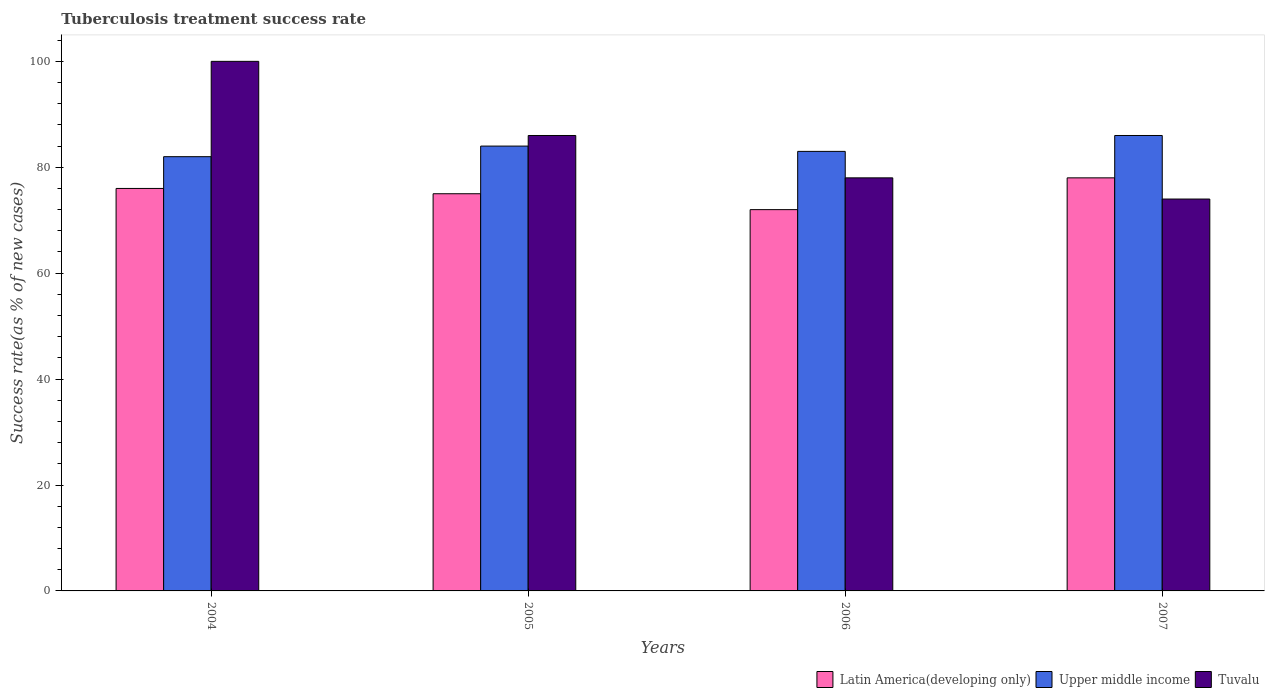How many groups of bars are there?
Your answer should be compact. 4. How many bars are there on the 1st tick from the right?
Offer a terse response. 3. What is the label of the 1st group of bars from the left?
Your answer should be very brief. 2004. In how many cases, is the number of bars for a given year not equal to the number of legend labels?
Offer a very short reply. 0. What is the tuberculosis treatment success rate in Upper middle income in 2006?
Keep it short and to the point. 83. Across all years, what is the maximum tuberculosis treatment success rate in Upper middle income?
Keep it short and to the point. 86. Across all years, what is the minimum tuberculosis treatment success rate in Upper middle income?
Your response must be concise. 82. In which year was the tuberculosis treatment success rate in Upper middle income minimum?
Provide a short and direct response. 2004. What is the total tuberculosis treatment success rate in Tuvalu in the graph?
Give a very brief answer. 338. What is the difference between the tuberculosis treatment success rate in Upper middle income in 2004 and that in 2005?
Offer a very short reply. -2. What is the difference between the tuberculosis treatment success rate in Upper middle income in 2005 and the tuberculosis treatment success rate in Latin America(developing only) in 2006?
Your answer should be very brief. 12. What is the average tuberculosis treatment success rate in Tuvalu per year?
Ensure brevity in your answer.  84.5. What is the ratio of the tuberculosis treatment success rate in Tuvalu in 2006 to that in 2007?
Give a very brief answer. 1.05. Is the difference between the tuberculosis treatment success rate in Latin America(developing only) in 2004 and 2005 greater than the difference between the tuberculosis treatment success rate in Tuvalu in 2004 and 2005?
Your answer should be very brief. No. What is the difference between the highest and the second highest tuberculosis treatment success rate in Latin America(developing only)?
Your response must be concise. 2. What is the difference between the highest and the lowest tuberculosis treatment success rate in Latin America(developing only)?
Your answer should be very brief. 6. In how many years, is the tuberculosis treatment success rate in Upper middle income greater than the average tuberculosis treatment success rate in Upper middle income taken over all years?
Give a very brief answer. 2. Is the sum of the tuberculosis treatment success rate in Latin America(developing only) in 2006 and 2007 greater than the maximum tuberculosis treatment success rate in Upper middle income across all years?
Offer a terse response. Yes. What does the 2nd bar from the left in 2005 represents?
Keep it short and to the point. Upper middle income. What does the 1st bar from the right in 2006 represents?
Offer a terse response. Tuvalu. How many bars are there?
Offer a very short reply. 12. Are all the bars in the graph horizontal?
Give a very brief answer. No. How many years are there in the graph?
Your answer should be compact. 4. What is the difference between two consecutive major ticks on the Y-axis?
Offer a terse response. 20. How are the legend labels stacked?
Provide a succinct answer. Horizontal. What is the title of the graph?
Offer a terse response. Tuberculosis treatment success rate. Does "Other small states" appear as one of the legend labels in the graph?
Ensure brevity in your answer.  No. What is the label or title of the X-axis?
Your answer should be very brief. Years. What is the label or title of the Y-axis?
Provide a short and direct response. Success rate(as % of new cases). What is the Success rate(as % of new cases) in Upper middle income in 2004?
Ensure brevity in your answer.  82. What is the Success rate(as % of new cases) in Latin America(developing only) in 2005?
Your answer should be very brief. 75. What is the Success rate(as % of new cases) in Upper middle income in 2005?
Keep it short and to the point. 84. What is the Success rate(as % of new cases) of Upper middle income in 2006?
Your answer should be very brief. 83. What is the Success rate(as % of new cases) of Latin America(developing only) in 2007?
Your answer should be compact. 78. Across all years, what is the maximum Success rate(as % of new cases) of Upper middle income?
Make the answer very short. 86. Across all years, what is the minimum Success rate(as % of new cases) in Latin America(developing only)?
Offer a very short reply. 72. What is the total Success rate(as % of new cases) in Latin America(developing only) in the graph?
Your response must be concise. 301. What is the total Success rate(as % of new cases) of Upper middle income in the graph?
Keep it short and to the point. 335. What is the total Success rate(as % of new cases) in Tuvalu in the graph?
Give a very brief answer. 338. What is the difference between the Success rate(as % of new cases) of Latin America(developing only) in 2004 and that in 2005?
Keep it short and to the point. 1. What is the difference between the Success rate(as % of new cases) of Tuvalu in 2004 and that in 2005?
Offer a very short reply. 14. What is the difference between the Success rate(as % of new cases) of Latin America(developing only) in 2004 and that in 2006?
Your response must be concise. 4. What is the difference between the Success rate(as % of new cases) in Tuvalu in 2004 and that in 2006?
Keep it short and to the point. 22. What is the difference between the Success rate(as % of new cases) in Latin America(developing only) in 2004 and that in 2007?
Your response must be concise. -2. What is the difference between the Success rate(as % of new cases) in Upper middle income in 2004 and that in 2007?
Give a very brief answer. -4. What is the difference between the Success rate(as % of new cases) of Latin America(developing only) in 2005 and that in 2006?
Provide a short and direct response. 3. What is the difference between the Success rate(as % of new cases) in Tuvalu in 2005 and that in 2007?
Make the answer very short. 12. What is the difference between the Success rate(as % of new cases) of Latin America(developing only) in 2006 and that in 2007?
Give a very brief answer. -6. What is the difference between the Success rate(as % of new cases) of Tuvalu in 2006 and that in 2007?
Your answer should be very brief. 4. What is the difference between the Success rate(as % of new cases) in Latin America(developing only) in 2004 and the Success rate(as % of new cases) in Upper middle income in 2006?
Ensure brevity in your answer.  -7. What is the difference between the Success rate(as % of new cases) in Latin America(developing only) in 2004 and the Success rate(as % of new cases) in Tuvalu in 2006?
Your answer should be compact. -2. What is the difference between the Success rate(as % of new cases) of Latin America(developing only) in 2004 and the Success rate(as % of new cases) of Upper middle income in 2007?
Your answer should be compact. -10. What is the difference between the Success rate(as % of new cases) in Upper middle income in 2004 and the Success rate(as % of new cases) in Tuvalu in 2007?
Offer a very short reply. 8. What is the difference between the Success rate(as % of new cases) of Latin America(developing only) in 2005 and the Success rate(as % of new cases) of Upper middle income in 2006?
Your answer should be compact. -8. What is the difference between the Success rate(as % of new cases) in Latin America(developing only) in 2006 and the Success rate(as % of new cases) in Tuvalu in 2007?
Ensure brevity in your answer.  -2. What is the average Success rate(as % of new cases) in Latin America(developing only) per year?
Keep it short and to the point. 75.25. What is the average Success rate(as % of new cases) of Upper middle income per year?
Make the answer very short. 83.75. What is the average Success rate(as % of new cases) of Tuvalu per year?
Ensure brevity in your answer.  84.5. In the year 2004, what is the difference between the Success rate(as % of new cases) of Upper middle income and Success rate(as % of new cases) of Tuvalu?
Keep it short and to the point. -18. In the year 2005, what is the difference between the Success rate(as % of new cases) in Latin America(developing only) and Success rate(as % of new cases) in Upper middle income?
Your answer should be very brief. -9. In the year 2005, what is the difference between the Success rate(as % of new cases) of Upper middle income and Success rate(as % of new cases) of Tuvalu?
Provide a succinct answer. -2. In the year 2006, what is the difference between the Success rate(as % of new cases) in Latin America(developing only) and Success rate(as % of new cases) in Upper middle income?
Your answer should be very brief. -11. In the year 2007, what is the difference between the Success rate(as % of new cases) in Latin America(developing only) and Success rate(as % of new cases) in Upper middle income?
Offer a very short reply. -8. What is the ratio of the Success rate(as % of new cases) in Latin America(developing only) in 2004 to that in 2005?
Keep it short and to the point. 1.01. What is the ratio of the Success rate(as % of new cases) of Upper middle income in 2004 to that in 2005?
Your answer should be very brief. 0.98. What is the ratio of the Success rate(as % of new cases) of Tuvalu in 2004 to that in 2005?
Offer a very short reply. 1.16. What is the ratio of the Success rate(as % of new cases) in Latin America(developing only) in 2004 to that in 2006?
Your answer should be very brief. 1.06. What is the ratio of the Success rate(as % of new cases) in Upper middle income in 2004 to that in 2006?
Provide a short and direct response. 0.99. What is the ratio of the Success rate(as % of new cases) in Tuvalu in 2004 to that in 2006?
Offer a very short reply. 1.28. What is the ratio of the Success rate(as % of new cases) of Latin America(developing only) in 2004 to that in 2007?
Ensure brevity in your answer.  0.97. What is the ratio of the Success rate(as % of new cases) in Upper middle income in 2004 to that in 2007?
Your answer should be very brief. 0.95. What is the ratio of the Success rate(as % of new cases) of Tuvalu in 2004 to that in 2007?
Your answer should be very brief. 1.35. What is the ratio of the Success rate(as % of new cases) of Latin America(developing only) in 2005 to that in 2006?
Ensure brevity in your answer.  1.04. What is the ratio of the Success rate(as % of new cases) of Upper middle income in 2005 to that in 2006?
Make the answer very short. 1.01. What is the ratio of the Success rate(as % of new cases) of Tuvalu in 2005 to that in 2006?
Offer a terse response. 1.1. What is the ratio of the Success rate(as % of new cases) in Latin America(developing only) in 2005 to that in 2007?
Keep it short and to the point. 0.96. What is the ratio of the Success rate(as % of new cases) in Upper middle income in 2005 to that in 2007?
Keep it short and to the point. 0.98. What is the ratio of the Success rate(as % of new cases) of Tuvalu in 2005 to that in 2007?
Ensure brevity in your answer.  1.16. What is the ratio of the Success rate(as % of new cases) in Upper middle income in 2006 to that in 2007?
Provide a succinct answer. 0.97. What is the ratio of the Success rate(as % of new cases) of Tuvalu in 2006 to that in 2007?
Keep it short and to the point. 1.05. What is the difference between the highest and the second highest Success rate(as % of new cases) in Upper middle income?
Offer a very short reply. 2. What is the difference between the highest and the second highest Success rate(as % of new cases) of Tuvalu?
Give a very brief answer. 14. 